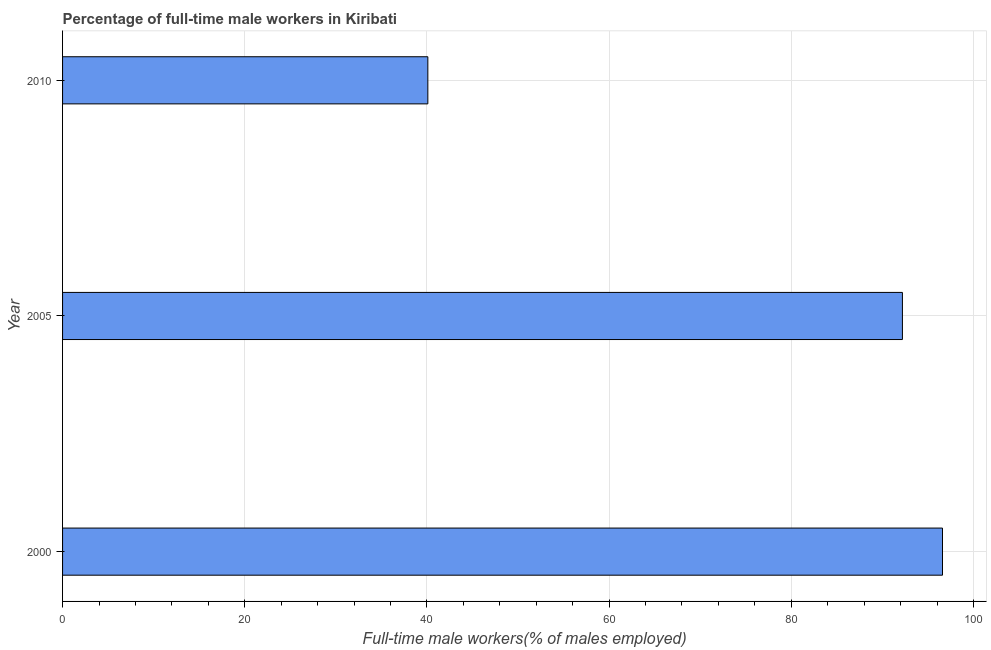Does the graph contain grids?
Offer a very short reply. Yes. What is the title of the graph?
Offer a very short reply. Percentage of full-time male workers in Kiribati. What is the label or title of the X-axis?
Make the answer very short. Full-time male workers(% of males employed). What is the label or title of the Y-axis?
Ensure brevity in your answer.  Year. What is the percentage of full-time male workers in 2000?
Ensure brevity in your answer.  96.6. Across all years, what is the maximum percentage of full-time male workers?
Give a very brief answer. 96.6. Across all years, what is the minimum percentage of full-time male workers?
Keep it short and to the point. 40.1. What is the sum of the percentage of full-time male workers?
Your answer should be very brief. 228.9. What is the difference between the percentage of full-time male workers in 2005 and 2010?
Keep it short and to the point. 52.1. What is the average percentage of full-time male workers per year?
Offer a very short reply. 76.3. What is the median percentage of full-time male workers?
Provide a short and direct response. 92.2. In how many years, is the percentage of full-time male workers greater than 20 %?
Give a very brief answer. 3. Do a majority of the years between 2000 and 2005 (inclusive) have percentage of full-time male workers greater than 52 %?
Your answer should be compact. Yes. What is the ratio of the percentage of full-time male workers in 2005 to that in 2010?
Your answer should be very brief. 2.3. What is the difference between the highest and the second highest percentage of full-time male workers?
Your response must be concise. 4.4. What is the difference between the highest and the lowest percentage of full-time male workers?
Provide a short and direct response. 56.5. How many bars are there?
Give a very brief answer. 3. How many years are there in the graph?
Give a very brief answer. 3. What is the difference between two consecutive major ticks on the X-axis?
Provide a succinct answer. 20. What is the Full-time male workers(% of males employed) of 2000?
Your response must be concise. 96.6. What is the Full-time male workers(% of males employed) of 2005?
Your answer should be very brief. 92.2. What is the Full-time male workers(% of males employed) in 2010?
Offer a very short reply. 40.1. What is the difference between the Full-time male workers(% of males employed) in 2000 and 2010?
Offer a terse response. 56.5. What is the difference between the Full-time male workers(% of males employed) in 2005 and 2010?
Ensure brevity in your answer.  52.1. What is the ratio of the Full-time male workers(% of males employed) in 2000 to that in 2005?
Provide a short and direct response. 1.05. What is the ratio of the Full-time male workers(% of males employed) in 2000 to that in 2010?
Keep it short and to the point. 2.41. What is the ratio of the Full-time male workers(% of males employed) in 2005 to that in 2010?
Your response must be concise. 2.3. 